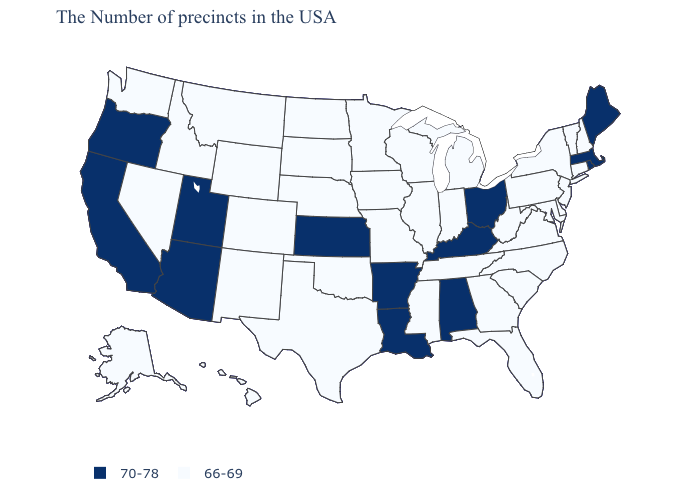Among the states that border Texas , which have the lowest value?
Concise answer only. Oklahoma, New Mexico. What is the lowest value in states that border West Virginia?
Short answer required. 66-69. What is the lowest value in the West?
Concise answer only. 66-69. Name the states that have a value in the range 66-69?
Short answer required. New Hampshire, Vermont, Connecticut, New York, New Jersey, Delaware, Maryland, Pennsylvania, Virginia, North Carolina, South Carolina, West Virginia, Florida, Georgia, Michigan, Indiana, Tennessee, Wisconsin, Illinois, Mississippi, Missouri, Minnesota, Iowa, Nebraska, Oklahoma, Texas, South Dakota, North Dakota, Wyoming, Colorado, New Mexico, Montana, Idaho, Nevada, Washington, Alaska, Hawaii. Name the states that have a value in the range 70-78?
Be succinct. Maine, Massachusetts, Rhode Island, Ohio, Kentucky, Alabama, Louisiana, Arkansas, Kansas, Utah, Arizona, California, Oregon. Does Kansas have the lowest value in the MidWest?
Answer briefly. No. What is the value of West Virginia?
Keep it brief. 66-69. Name the states that have a value in the range 66-69?
Quick response, please. New Hampshire, Vermont, Connecticut, New York, New Jersey, Delaware, Maryland, Pennsylvania, Virginia, North Carolina, South Carolina, West Virginia, Florida, Georgia, Michigan, Indiana, Tennessee, Wisconsin, Illinois, Mississippi, Missouri, Minnesota, Iowa, Nebraska, Oklahoma, Texas, South Dakota, North Dakota, Wyoming, Colorado, New Mexico, Montana, Idaho, Nevada, Washington, Alaska, Hawaii. Does the first symbol in the legend represent the smallest category?
Short answer required. No. What is the highest value in the Northeast ?
Give a very brief answer. 70-78. What is the value of North Carolina?
Short answer required. 66-69. Does Kentucky have the highest value in the USA?
Give a very brief answer. Yes. Does the map have missing data?
Write a very short answer. No. 